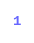Convert code to text. <code><loc_0><loc_0><loc_500><loc_500><_C++_>1</code> 